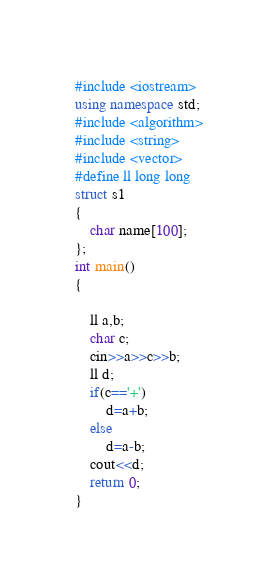<code> <loc_0><loc_0><loc_500><loc_500><_C++_>#include <iostream>
using namespace std;
#include <algorithm>
#include <string>
#include <vector>
#define ll long long
struct s1
{
    char name[100];
};
int main()
{

    ll a,b;
    char c;
    cin>>a>>c>>b;
    ll d;
    if(c=='+')
        d=a+b;
    else
        d=a-b;
    cout<<d;
    return 0;
}
</code> 